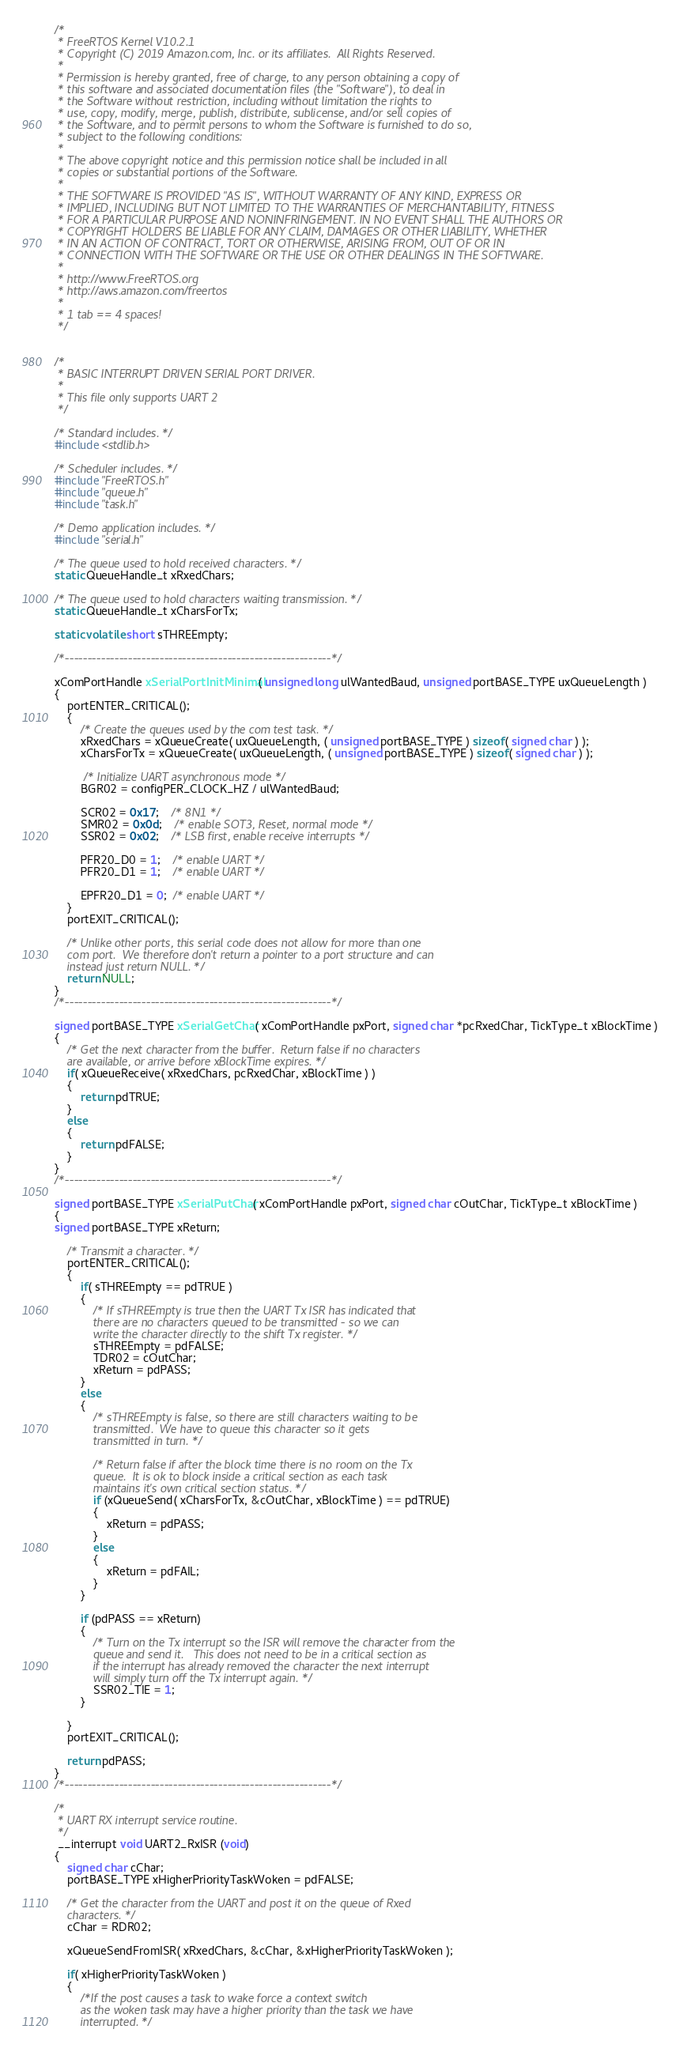<code> <loc_0><loc_0><loc_500><loc_500><_C_>/*
 * FreeRTOS Kernel V10.2.1
 * Copyright (C) 2019 Amazon.com, Inc. or its affiliates.  All Rights Reserved.
 *
 * Permission is hereby granted, free of charge, to any person obtaining a copy of
 * this software and associated documentation files (the "Software"), to deal in
 * the Software without restriction, including without limitation the rights to
 * use, copy, modify, merge, publish, distribute, sublicense, and/or sell copies of
 * the Software, and to permit persons to whom the Software is furnished to do so,
 * subject to the following conditions:
 *
 * The above copyright notice and this permission notice shall be included in all
 * copies or substantial portions of the Software.
 *
 * THE SOFTWARE IS PROVIDED "AS IS", WITHOUT WARRANTY OF ANY KIND, EXPRESS OR
 * IMPLIED, INCLUDING BUT NOT LIMITED TO THE WARRANTIES OF MERCHANTABILITY, FITNESS
 * FOR A PARTICULAR PURPOSE AND NONINFRINGEMENT. IN NO EVENT SHALL THE AUTHORS OR
 * COPYRIGHT HOLDERS BE LIABLE FOR ANY CLAIM, DAMAGES OR OTHER LIABILITY, WHETHER
 * IN AN ACTION OF CONTRACT, TORT OR OTHERWISE, ARISING FROM, OUT OF OR IN
 * CONNECTION WITH THE SOFTWARE OR THE USE OR OTHER DEALINGS IN THE SOFTWARE.
 *
 * http://www.FreeRTOS.org
 * http://aws.amazon.com/freertos
 *
 * 1 tab == 4 spaces!
 */


/* 
 * BASIC INTERRUPT DRIVEN SERIAL PORT DRIVER.   
 * 
 * This file only supports UART 2
 */

/* Standard includes. */
#include <stdlib.h>

/* Scheduler includes. */
#include "FreeRTOS.h"
#include "queue.h"
#include "task.h"

/* Demo application includes. */
#include "serial.h"

/* The queue used to hold received characters. */
static QueueHandle_t xRxedChars; 

/* The queue used to hold characters waiting transmission. */
static QueueHandle_t xCharsForTx; 

static volatile short sTHREEmpty;

/*-----------------------------------------------------------*/

xComPortHandle xSerialPortInitMinimal( unsigned long ulWantedBaud, unsigned portBASE_TYPE uxQueueLength )
{
	portENTER_CRITICAL();
	{
		/* Create the queues used by the com test task. */
		xRxedChars = xQueueCreate( uxQueueLength, ( unsigned portBASE_TYPE ) sizeof( signed char ) );
		xCharsForTx = xQueueCreate( uxQueueLength, ( unsigned portBASE_TYPE ) sizeof( signed char ) );

		 /* Initialize UART asynchronous mode */
		BGR02 = configPER_CLOCK_HZ / ulWantedBaud;
		  
		SCR02 = 0x17;	/* 8N1 */
		SMR02 = 0x0d;	/* enable SOT3, Reset, normal mode */
		SSR02 = 0x02;	/* LSB first, enable receive interrupts */

		PFR20_D0 = 1;	/* enable UART */
		PFR20_D1 = 1;	/* enable UART */

		EPFR20_D1 = 0;  /* enable UART */
	}
	portEXIT_CRITICAL();
	
	/* Unlike other ports, this serial code does not allow for more than one
	com port.  We therefore don't return a pointer to a port structure and can
	instead just return NULL. */
	return NULL;
}
/*-----------------------------------------------------------*/

signed portBASE_TYPE xSerialGetChar( xComPortHandle pxPort, signed char *pcRxedChar, TickType_t xBlockTime )
{
	/* Get the next character from the buffer.  Return false if no characters
	are available, or arrive before xBlockTime expires. */
	if( xQueueReceive( xRxedChars, pcRxedChar, xBlockTime ) )
	{
		return pdTRUE;
	}
	else
	{
		return pdFALSE;
	}
}
/*-----------------------------------------------------------*/

signed portBASE_TYPE xSerialPutChar( xComPortHandle pxPort, signed char cOutChar, TickType_t xBlockTime )
{
signed portBASE_TYPE xReturn;

	/* Transmit a character. */
	portENTER_CRITICAL();
	{
		if( sTHREEmpty == pdTRUE )
		{
			/* If sTHREEmpty is true then the UART Tx ISR has indicated that 
			there are no characters queued to be transmitted - so we can
			write the character directly to the shift Tx register. */
			sTHREEmpty = pdFALSE;
			TDR02 = cOutChar;
			xReturn = pdPASS;
		}
		else
		{
			/* sTHREEmpty is false, so there are still characters waiting to be
			transmitted.  We have to queue this character so it gets 
			transmitted	in turn. */

			/* Return false if after the block time there is no room on the Tx 
			queue.  It is ok to block inside a critical section as each task
			maintains it's own critical section status. */
			if (xQueueSend( xCharsForTx, &cOutChar, xBlockTime ) == pdTRUE)
			{
				xReturn = pdPASS;
			}
			else
			{
				xReturn = pdFAIL;
			}
		}
		
		if (pdPASS == xReturn)
		{
			/* Turn on the Tx interrupt so the ISR will remove the character from the
			queue and send it.   This does not need to be in a critical section as
			if the interrupt has already removed the character the next interrupt
			will simply turn off the Tx interrupt again. */
			SSR02_TIE = 1;
		}
		
	}
	portEXIT_CRITICAL();

	return pdPASS;
}
/*-----------------------------------------------------------*/

/*
 * UART RX interrupt service routine.
 */
 __interrupt void UART2_RxISR (void)
{
	signed char cChar;
	portBASE_TYPE xHigherPriorityTaskWoken = pdFALSE;

	/* Get the character from the UART and post it on the queue of Rxed 
	characters. */
	cChar = RDR02;

	xQueueSendFromISR( xRxedChars, &cChar, &xHigherPriorityTaskWoken );

	if( xHigherPriorityTaskWoken )
	{
		/*If the post causes a task to wake force a context switch 
		as the woken task may have a higher priority than the task we have 
		interrupted. */</code> 